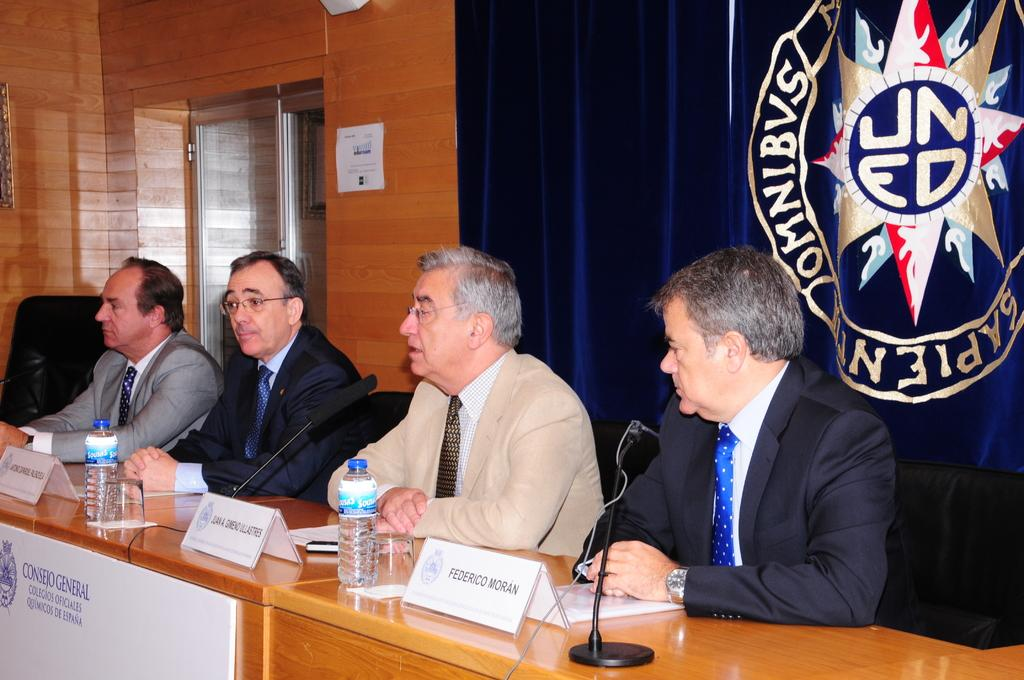Provide a one-sentence caption for the provided image. a few men including one with the name federico in front of them. 